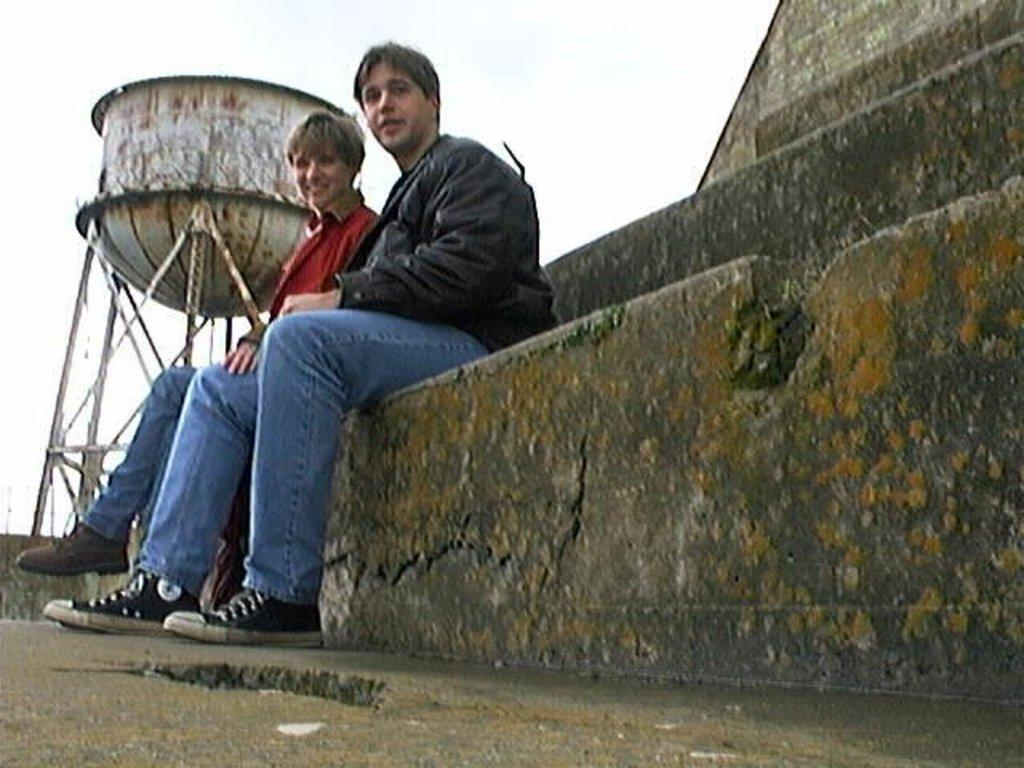How many people are in the image? There are two persons in the image. What are the people doing in the image? The two persons are sitting on a rock. What can be seen on the left side of the image? There is a water tank visible on the left side of the image. What is visible at the top of the image? The sky is visible at the top of the image. What type of line is being used to stop the water flow from the water tank in the image? There is no line visible in the image to stop the water flow from the water tank. 